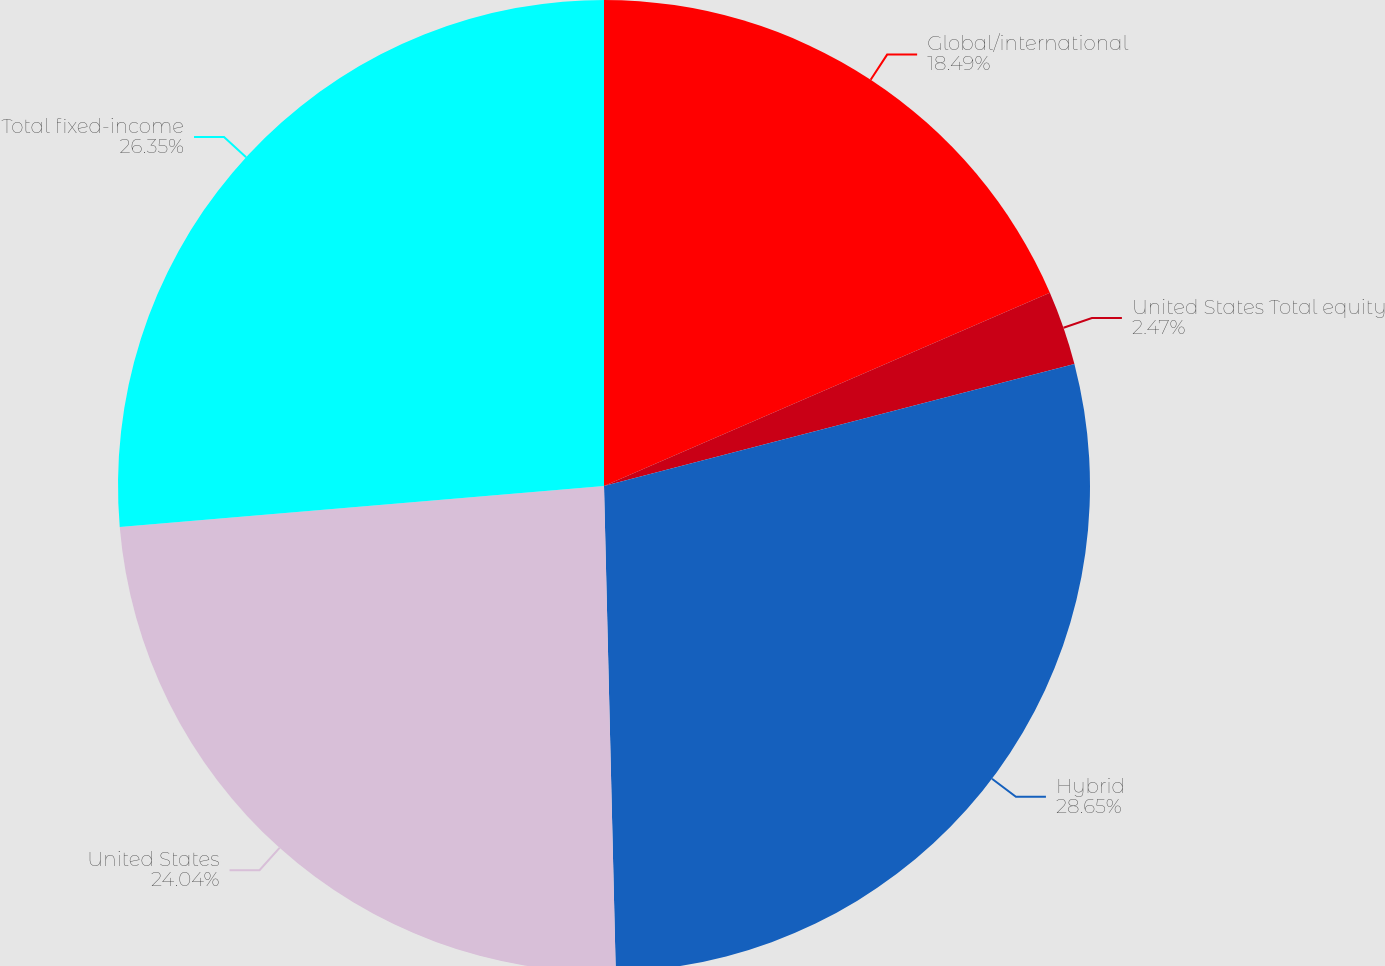Convert chart to OTSL. <chart><loc_0><loc_0><loc_500><loc_500><pie_chart><fcel>Global/international<fcel>United States Total equity<fcel>Hybrid<fcel>United States<fcel>Total fixed-income<nl><fcel>18.49%<fcel>2.47%<fcel>28.66%<fcel>24.04%<fcel>26.35%<nl></chart> 